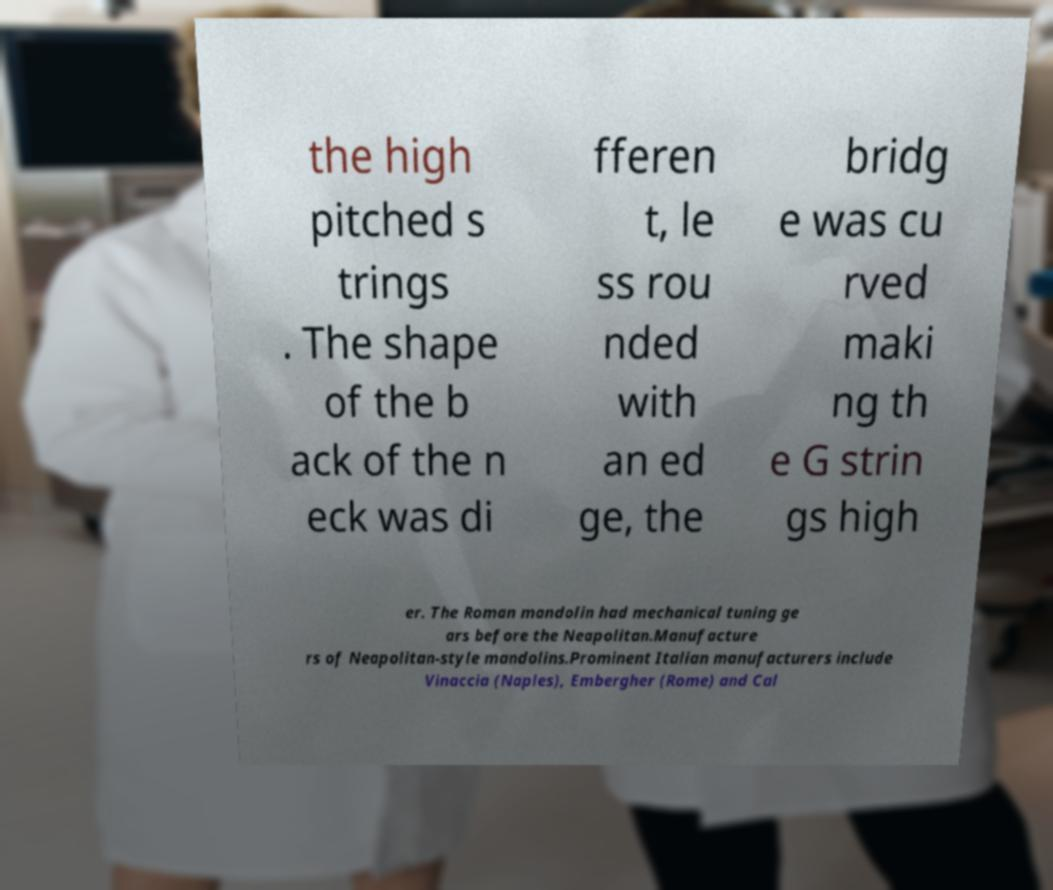Could you extract and type out the text from this image? the high pitched s trings . The shape of the b ack of the n eck was di fferen t, le ss rou nded with an ed ge, the bridg e was cu rved maki ng th e G strin gs high er. The Roman mandolin had mechanical tuning ge ars before the Neapolitan.Manufacture rs of Neapolitan-style mandolins.Prominent Italian manufacturers include Vinaccia (Naples), Embergher (Rome) and Cal 